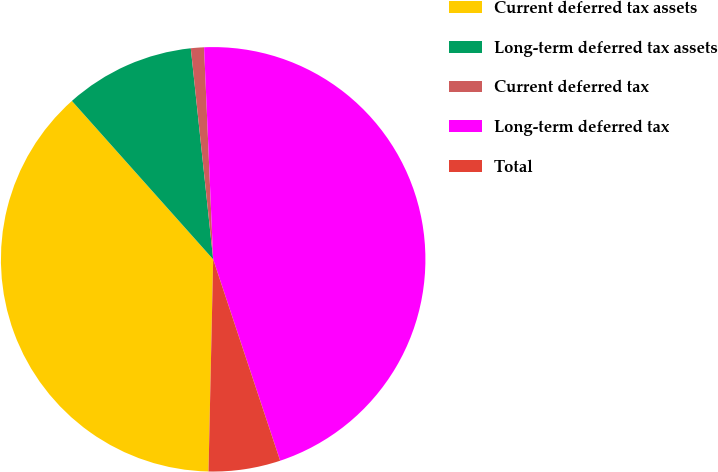Convert chart. <chart><loc_0><loc_0><loc_500><loc_500><pie_chart><fcel>Current deferred tax assets<fcel>Long-term deferred tax assets<fcel>Current deferred tax<fcel>Long-term deferred tax<fcel>Total<nl><fcel>38.06%<fcel>9.91%<fcel>1.0%<fcel>45.57%<fcel>5.46%<nl></chart> 